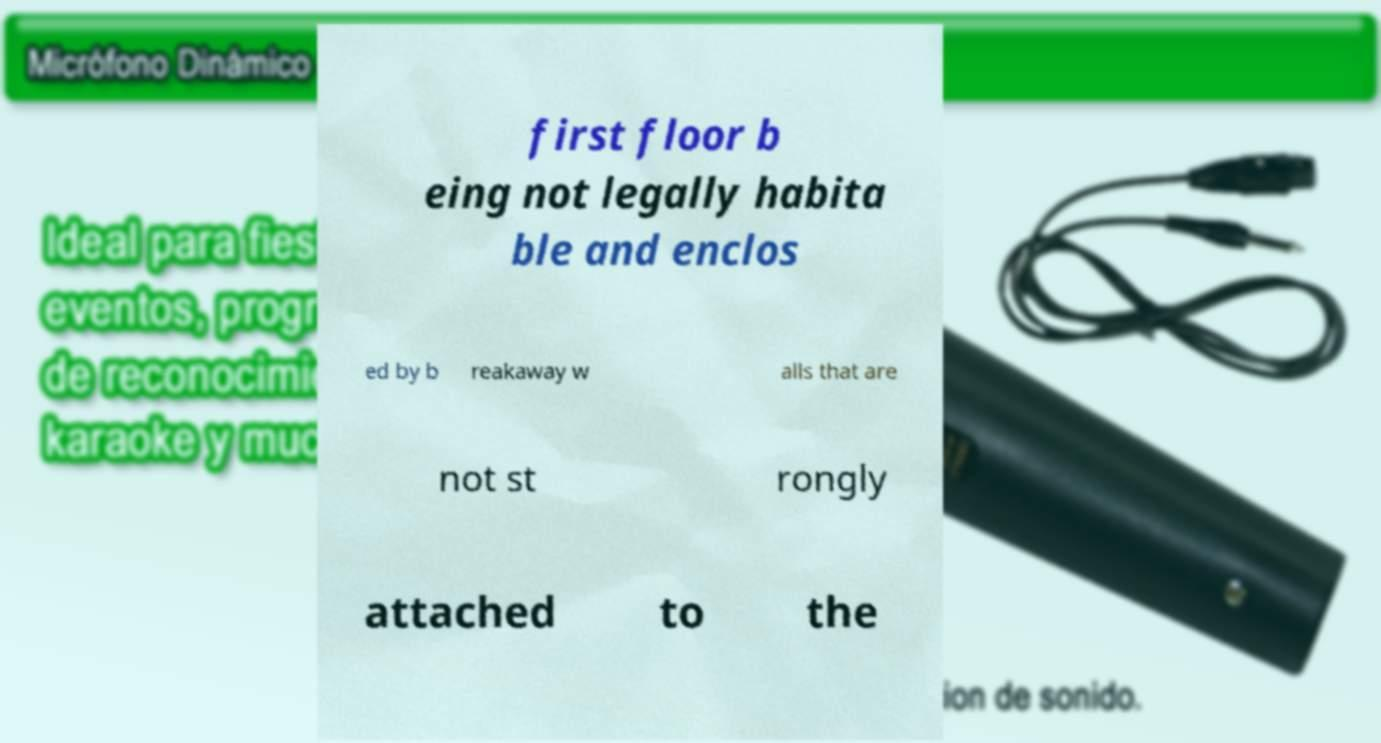There's text embedded in this image that I need extracted. Can you transcribe it verbatim? first floor b eing not legally habita ble and enclos ed by b reakaway w alls that are not st rongly attached to the 